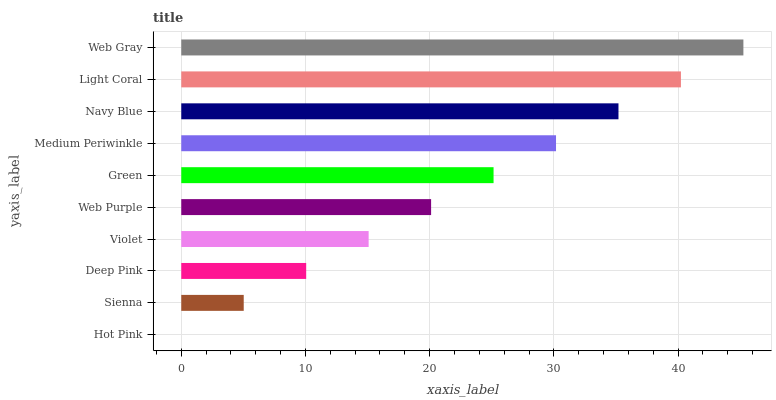Is Hot Pink the minimum?
Answer yes or no. Yes. Is Web Gray the maximum?
Answer yes or no. Yes. Is Sienna the minimum?
Answer yes or no. No. Is Sienna the maximum?
Answer yes or no. No. Is Sienna greater than Hot Pink?
Answer yes or no. Yes. Is Hot Pink less than Sienna?
Answer yes or no. Yes. Is Hot Pink greater than Sienna?
Answer yes or no. No. Is Sienna less than Hot Pink?
Answer yes or no. No. Is Green the high median?
Answer yes or no. Yes. Is Web Purple the low median?
Answer yes or no. Yes. Is Web Gray the high median?
Answer yes or no. No. Is Green the low median?
Answer yes or no. No. 